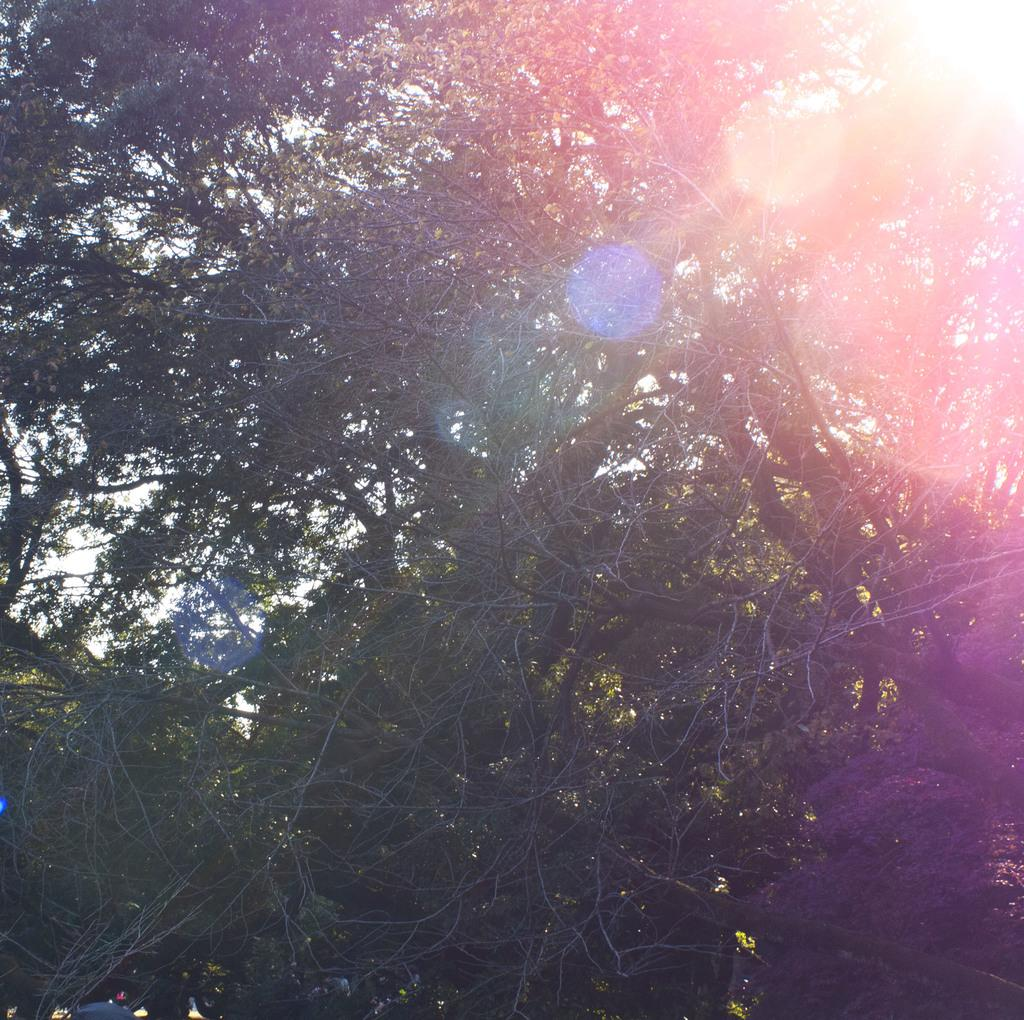What type of natural element is present in the image? There is a tree in the image. What is the weather like in the image? There is bright sunshine in the image. What part of the natural environment is visible in the image? The sky is visible in the image. What type of idea is being discussed by the servant in the foggy scene in the image? There is no servant or foggy scene present in the image; it features a tree and bright sunshine. 